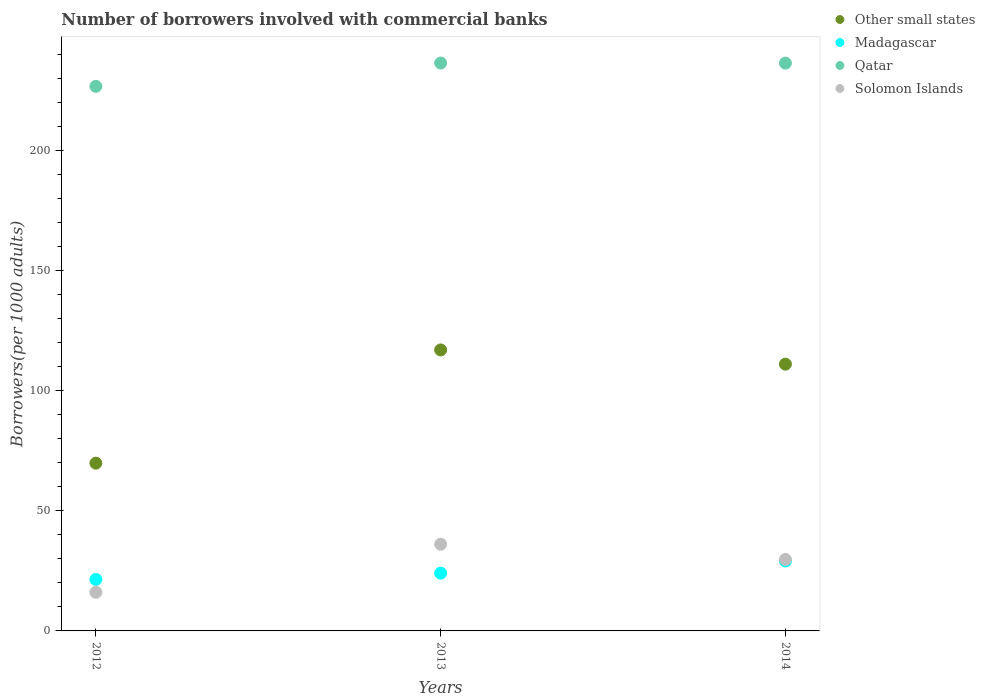How many different coloured dotlines are there?
Make the answer very short. 4. What is the number of borrowers involved with commercial banks in Other small states in 2013?
Make the answer very short. 117.06. Across all years, what is the maximum number of borrowers involved with commercial banks in Solomon Islands?
Offer a terse response. 36.11. Across all years, what is the minimum number of borrowers involved with commercial banks in Qatar?
Your answer should be compact. 226.87. In which year was the number of borrowers involved with commercial banks in Solomon Islands maximum?
Make the answer very short. 2013. In which year was the number of borrowers involved with commercial banks in Qatar minimum?
Your answer should be very brief. 2012. What is the total number of borrowers involved with commercial banks in Madagascar in the graph?
Provide a short and direct response. 74.66. What is the difference between the number of borrowers involved with commercial banks in Solomon Islands in 2012 and that in 2013?
Make the answer very short. -20.03. What is the difference between the number of borrowers involved with commercial banks in Madagascar in 2013 and the number of borrowers involved with commercial banks in Solomon Islands in 2014?
Provide a short and direct response. -5.71. What is the average number of borrowers involved with commercial banks in Qatar per year?
Make the answer very short. 233.34. In the year 2013, what is the difference between the number of borrowers involved with commercial banks in Other small states and number of borrowers involved with commercial banks in Madagascar?
Offer a very short reply. 92.99. What is the ratio of the number of borrowers involved with commercial banks in Other small states in 2012 to that in 2014?
Offer a terse response. 0.63. Is the difference between the number of borrowers involved with commercial banks in Other small states in 2013 and 2014 greater than the difference between the number of borrowers involved with commercial banks in Madagascar in 2013 and 2014?
Provide a succinct answer. Yes. What is the difference between the highest and the second highest number of borrowers involved with commercial banks in Solomon Islands?
Offer a terse response. 6.33. What is the difference between the highest and the lowest number of borrowers involved with commercial banks in Qatar?
Ensure brevity in your answer.  9.71. In how many years, is the number of borrowers involved with commercial banks in Other small states greater than the average number of borrowers involved with commercial banks in Other small states taken over all years?
Provide a succinct answer. 2. Is it the case that in every year, the sum of the number of borrowers involved with commercial banks in Madagascar and number of borrowers involved with commercial banks in Solomon Islands  is greater than the sum of number of borrowers involved with commercial banks in Other small states and number of borrowers involved with commercial banks in Qatar?
Keep it short and to the point. No. Is the number of borrowers involved with commercial banks in Solomon Islands strictly less than the number of borrowers involved with commercial banks in Other small states over the years?
Offer a terse response. Yes. How many dotlines are there?
Keep it short and to the point. 4. How many years are there in the graph?
Provide a short and direct response. 3. What is the difference between two consecutive major ticks on the Y-axis?
Ensure brevity in your answer.  50. Are the values on the major ticks of Y-axis written in scientific E-notation?
Offer a terse response. No. Does the graph contain any zero values?
Your answer should be very brief. No. Does the graph contain grids?
Your response must be concise. No. Where does the legend appear in the graph?
Offer a terse response. Top right. How many legend labels are there?
Your answer should be compact. 4. How are the legend labels stacked?
Provide a short and direct response. Vertical. What is the title of the graph?
Your answer should be compact. Number of borrowers involved with commercial banks. What is the label or title of the Y-axis?
Provide a short and direct response. Borrowers(per 1000 adults). What is the Borrowers(per 1000 adults) of Other small states in 2012?
Ensure brevity in your answer.  69.88. What is the Borrowers(per 1000 adults) of Madagascar in 2012?
Your response must be concise. 21.46. What is the Borrowers(per 1000 adults) in Qatar in 2012?
Give a very brief answer. 226.87. What is the Borrowers(per 1000 adults) in Solomon Islands in 2012?
Your answer should be very brief. 16.09. What is the Borrowers(per 1000 adults) in Other small states in 2013?
Give a very brief answer. 117.06. What is the Borrowers(per 1000 adults) in Madagascar in 2013?
Ensure brevity in your answer.  24.07. What is the Borrowers(per 1000 adults) of Qatar in 2013?
Your answer should be compact. 236.58. What is the Borrowers(per 1000 adults) in Solomon Islands in 2013?
Offer a very short reply. 36.11. What is the Borrowers(per 1000 adults) of Other small states in 2014?
Offer a terse response. 111.14. What is the Borrowers(per 1000 adults) in Madagascar in 2014?
Offer a terse response. 29.13. What is the Borrowers(per 1000 adults) of Qatar in 2014?
Your answer should be compact. 236.55. What is the Borrowers(per 1000 adults) in Solomon Islands in 2014?
Give a very brief answer. 29.78. Across all years, what is the maximum Borrowers(per 1000 adults) of Other small states?
Provide a short and direct response. 117.06. Across all years, what is the maximum Borrowers(per 1000 adults) of Madagascar?
Your response must be concise. 29.13. Across all years, what is the maximum Borrowers(per 1000 adults) in Qatar?
Provide a short and direct response. 236.58. Across all years, what is the maximum Borrowers(per 1000 adults) in Solomon Islands?
Your response must be concise. 36.11. Across all years, what is the minimum Borrowers(per 1000 adults) in Other small states?
Provide a succinct answer. 69.88. Across all years, what is the minimum Borrowers(per 1000 adults) of Madagascar?
Give a very brief answer. 21.46. Across all years, what is the minimum Borrowers(per 1000 adults) of Qatar?
Your response must be concise. 226.87. Across all years, what is the minimum Borrowers(per 1000 adults) in Solomon Islands?
Ensure brevity in your answer.  16.09. What is the total Borrowers(per 1000 adults) in Other small states in the graph?
Offer a terse response. 298.08. What is the total Borrowers(per 1000 adults) in Madagascar in the graph?
Offer a very short reply. 74.66. What is the total Borrowers(per 1000 adults) in Qatar in the graph?
Offer a very short reply. 700.01. What is the total Borrowers(per 1000 adults) in Solomon Islands in the graph?
Provide a succinct answer. 81.98. What is the difference between the Borrowers(per 1000 adults) in Other small states in 2012 and that in 2013?
Ensure brevity in your answer.  -47.18. What is the difference between the Borrowers(per 1000 adults) of Madagascar in 2012 and that in 2013?
Make the answer very short. -2.61. What is the difference between the Borrowers(per 1000 adults) in Qatar in 2012 and that in 2013?
Give a very brief answer. -9.71. What is the difference between the Borrowers(per 1000 adults) in Solomon Islands in 2012 and that in 2013?
Your answer should be compact. -20.03. What is the difference between the Borrowers(per 1000 adults) in Other small states in 2012 and that in 2014?
Provide a short and direct response. -41.26. What is the difference between the Borrowers(per 1000 adults) of Madagascar in 2012 and that in 2014?
Make the answer very short. -7.68. What is the difference between the Borrowers(per 1000 adults) of Qatar in 2012 and that in 2014?
Your answer should be compact. -9.68. What is the difference between the Borrowers(per 1000 adults) in Solomon Islands in 2012 and that in 2014?
Give a very brief answer. -13.69. What is the difference between the Borrowers(per 1000 adults) in Other small states in 2013 and that in 2014?
Ensure brevity in your answer.  5.92. What is the difference between the Borrowers(per 1000 adults) of Madagascar in 2013 and that in 2014?
Offer a terse response. -5.07. What is the difference between the Borrowers(per 1000 adults) of Qatar in 2013 and that in 2014?
Offer a terse response. 0.04. What is the difference between the Borrowers(per 1000 adults) of Solomon Islands in 2013 and that in 2014?
Offer a very short reply. 6.33. What is the difference between the Borrowers(per 1000 adults) of Other small states in 2012 and the Borrowers(per 1000 adults) of Madagascar in 2013?
Give a very brief answer. 45.81. What is the difference between the Borrowers(per 1000 adults) in Other small states in 2012 and the Borrowers(per 1000 adults) in Qatar in 2013?
Keep it short and to the point. -166.7. What is the difference between the Borrowers(per 1000 adults) of Other small states in 2012 and the Borrowers(per 1000 adults) of Solomon Islands in 2013?
Give a very brief answer. 33.77. What is the difference between the Borrowers(per 1000 adults) in Madagascar in 2012 and the Borrowers(per 1000 adults) in Qatar in 2013?
Ensure brevity in your answer.  -215.13. What is the difference between the Borrowers(per 1000 adults) of Madagascar in 2012 and the Borrowers(per 1000 adults) of Solomon Islands in 2013?
Provide a short and direct response. -14.66. What is the difference between the Borrowers(per 1000 adults) of Qatar in 2012 and the Borrowers(per 1000 adults) of Solomon Islands in 2013?
Keep it short and to the point. 190.76. What is the difference between the Borrowers(per 1000 adults) in Other small states in 2012 and the Borrowers(per 1000 adults) in Madagascar in 2014?
Make the answer very short. 40.75. What is the difference between the Borrowers(per 1000 adults) in Other small states in 2012 and the Borrowers(per 1000 adults) in Qatar in 2014?
Your response must be concise. -166.67. What is the difference between the Borrowers(per 1000 adults) of Other small states in 2012 and the Borrowers(per 1000 adults) of Solomon Islands in 2014?
Your response must be concise. 40.1. What is the difference between the Borrowers(per 1000 adults) in Madagascar in 2012 and the Borrowers(per 1000 adults) in Qatar in 2014?
Offer a terse response. -215.09. What is the difference between the Borrowers(per 1000 adults) in Madagascar in 2012 and the Borrowers(per 1000 adults) in Solomon Islands in 2014?
Your answer should be very brief. -8.32. What is the difference between the Borrowers(per 1000 adults) of Qatar in 2012 and the Borrowers(per 1000 adults) of Solomon Islands in 2014?
Ensure brevity in your answer.  197.09. What is the difference between the Borrowers(per 1000 adults) in Other small states in 2013 and the Borrowers(per 1000 adults) in Madagascar in 2014?
Your answer should be very brief. 87.93. What is the difference between the Borrowers(per 1000 adults) of Other small states in 2013 and the Borrowers(per 1000 adults) of Qatar in 2014?
Offer a very short reply. -119.49. What is the difference between the Borrowers(per 1000 adults) in Other small states in 2013 and the Borrowers(per 1000 adults) in Solomon Islands in 2014?
Give a very brief answer. 87.28. What is the difference between the Borrowers(per 1000 adults) of Madagascar in 2013 and the Borrowers(per 1000 adults) of Qatar in 2014?
Ensure brevity in your answer.  -212.48. What is the difference between the Borrowers(per 1000 adults) of Madagascar in 2013 and the Borrowers(per 1000 adults) of Solomon Islands in 2014?
Your response must be concise. -5.71. What is the difference between the Borrowers(per 1000 adults) of Qatar in 2013 and the Borrowers(per 1000 adults) of Solomon Islands in 2014?
Offer a terse response. 206.8. What is the average Borrowers(per 1000 adults) of Other small states per year?
Offer a very short reply. 99.36. What is the average Borrowers(per 1000 adults) of Madagascar per year?
Your answer should be very brief. 24.89. What is the average Borrowers(per 1000 adults) in Qatar per year?
Give a very brief answer. 233.34. What is the average Borrowers(per 1000 adults) in Solomon Islands per year?
Your answer should be compact. 27.33. In the year 2012, what is the difference between the Borrowers(per 1000 adults) in Other small states and Borrowers(per 1000 adults) in Madagascar?
Offer a terse response. 48.42. In the year 2012, what is the difference between the Borrowers(per 1000 adults) of Other small states and Borrowers(per 1000 adults) of Qatar?
Offer a very short reply. -156.99. In the year 2012, what is the difference between the Borrowers(per 1000 adults) in Other small states and Borrowers(per 1000 adults) in Solomon Islands?
Your answer should be very brief. 53.79. In the year 2012, what is the difference between the Borrowers(per 1000 adults) in Madagascar and Borrowers(per 1000 adults) in Qatar?
Offer a terse response. -205.41. In the year 2012, what is the difference between the Borrowers(per 1000 adults) in Madagascar and Borrowers(per 1000 adults) in Solomon Islands?
Offer a very short reply. 5.37. In the year 2012, what is the difference between the Borrowers(per 1000 adults) in Qatar and Borrowers(per 1000 adults) in Solomon Islands?
Keep it short and to the point. 210.78. In the year 2013, what is the difference between the Borrowers(per 1000 adults) of Other small states and Borrowers(per 1000 adults) of Madagascar?
Your answer should be very brief. 92.99. In the year 2013, what is the difference between the Borrowers(per 1000 adults) of Other small states and Borrowers(per 1000 adults) of Qatar?
Provide a succinct answer. -119.52. In the year 2013, what is the difference between the Borrowers(per 1000 adults) of Other small states and Borrowers(per 1000 adults) of Solomon Islands?
Keep it short and to the point. 80.95. In the year 2013, what is the difference between the Borrowers(per 1000 adults) in Madagascar and Borrowers(per 1000 adults) in Qatar?
Provide a short and direct response. -212.52. In the year 2013, what is the difference between the Borrowers(per 1000 adults) of Madagascar and Borrowers(per 1000 adults) of Solomon Islands?
Ensure brevity in your answer.  -12.05. In the year 2013, what is the difference between the Borrowers(per 1000 adults) of Qatar and Borrowers(per 1000 adults) of Solomon Islands?
Your answer should be very brief. 200.47. In the year 2014, what is the difference between the Borrowers(per 1000 adults) of Other small states and Borrowers(per 1000 adults) of Madagascar?
Offer a terse response. 82.01. In the year 2014, what is the difference between the Borrowers(per 1000 adults) of Other small states and Borrowers(per 1000 adults) of Qatar?
Ensure brevity in your answer.  -125.41. In the year 2014, what is the difference between the Borrowers(per 1000 adults) in Other small states and Borrowers(per 1000 adults) in Solomon Islands?
Your answer should be very brief. 81.36. In the year 2014, what is the difference between the Borrowers(per 1000 adults) in Madagascar and Borrowers(per 1000 adults) in Qatar?
Your answer should be compact. -207.41. In the year 2014, what is the difference between the Borrowers(per 1000 adults) of Madagascar and Borrowers(per 1000 adults) of Solomon Islands?
Offer a very short reply. -0.65. In the year 2014, what is the difference between the Borrowers(per 1000 adults) of Qatar and Borrowers(per 1000 adults) of Solomon Islands?
Your answer should be compact. 206.77. What is the ratio of the Borrowers(per 1000 adults) of Other small states in 2012 to that in 2013?
Keep it short and to the point. 0.6. What is the ratio of the Borrowers(per 1000 adults) in Madagascar in 2012 to that in 2013?
Offer a terse response. 0.89. What is the ratio of the Borrowers(per 1000 adults) in Qatar in 2012 to that in 2013?
Offer a terse response. 0.96. What is the ratio of the Borrowers(per 1000 adults) in Solomon Islands in 2012 to that in 2013?
Offer a terse response. 0.45. What is the ratio of the Borrowers(per 1000 adults) in Other small states in 2012 to that in 2014?
Ensure brevity in your answer.  0.63. What is the ratio of the Borrowers(per 1000 adults) in Madagascar in 2012 to that in 2014?
Your answer should be compact. 0.74. What is the ratio of the Borrowers(per 1000 adults) in Qatar in 2012 to that in 2014?
Give a very brief answer. 0.96. What is the ratio of the Borrowers(per 1000 adults) in Solomon Islands in 2012 to that in 2014?
Ensure brevity in your answer.  0.54. What is the ratio of the Borrowers(per 1000 adults) in Other small states in 2013 to that in 2014?
Your response must be concise. 1.05. What is the ratio of the Borrowers(per 1000 adults) in Madagascar in 2013 to that in 2014?
Give a very brief answer. 0.83. What is the ratio of the Borrowers(per 1000 adults) of Qatar in 2013 to that in 2014?
Offer a terse response. 1. What is the ratio of the Borrowers(per 1000 adults) in Solomon Islands in 2013 to that in 2014?
Give a very brief answer. 1.21. What is the difference between the highest and the second highest Borrowers(per 1000 adults) of Other small states?
Offer a very short reply. 5.92. What is the difference between the highest and the second highest Borrowers(per 1000 adults) of Madagascar?
Provide a short and direct response. 5.07. What is the difference between the highest and the second highest Borrowers(per 1000 adults) in Qatar?
Your answer should be compact. 0.04. What is the difference between the highest and the second highest Borrowers(per 1000 adults) in Solomon Islands?
Your answer should be compact. 6.33. What is the difference between the highest and the lowest Borrowers(per 1000 adults) in Other small states?
Provide a short and direct response. 47.18. What is the difference between the highest and the lowest Borrowers(per 1000 adults) of Madagascar?
Offer a terse response. 7.68. What is the difference between the highest and the lowest Borrowers(per 1000 adults) in Qatar?
Keep it short and to the point. 9.71. What is the difference between the highest and the lowest Borrowers(per 1000 adults) in Solomon Islands?
Ensure brevity in your answer.  20.03. 